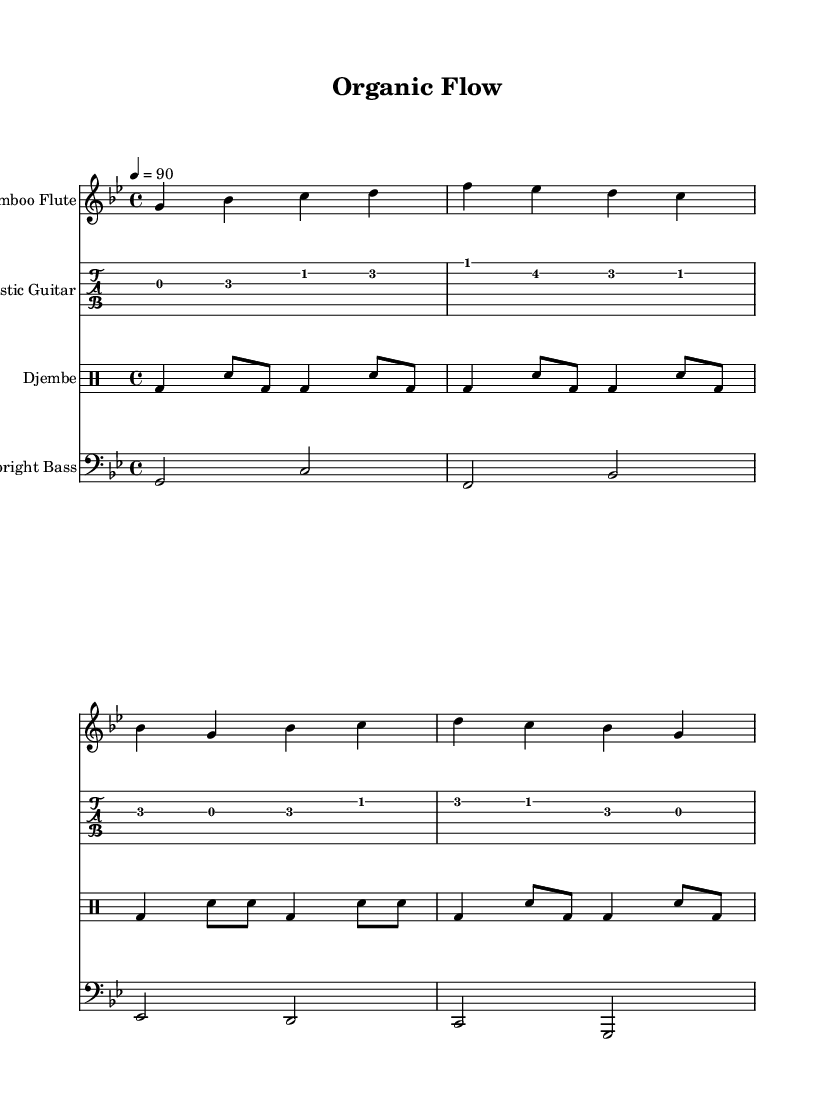What is the key signature of this music? The key signature is G minor, which has two flats (B flat and E flat).
Answer: G minor What is the time signature of the piece? The time signature is indicated prominently at the beginning and is 4/4, which means there are four beats in a measure.
Answer: 4/4 What is the tempo marking of the music? The tempo marking shows that the piece is to be played at 90 beats per minute, indicated using the quarter note symbol for tempo.
Answer: 90 How many instruments are featured in this piece? The score shows four distinct parts for different instruments: Bamboo Flute, Acoustic Guitar, Djembe, and Upright Bass, thus revealing the number of instruments.
Answer: Four Which instrument plays the melodic line? The Bamboo Flute is typically responsible for the melodic line in this composition and is written in the treble staff at the top of the score, showcasing its melody.
Answer: Bamboo Flute What percussion instrument is used in this arrangement? The Djembe is clearly indicated in the score as the percussion instrument that helps establish the rhythmic foundation.
Answer: Djembe What is the rhythmic structure represented in the djembe part? The rhythmic structure involves a pattern of bass and snare strokes within the 4/4 time, represented visually through quarter and eighth notes, which are essential for Hip Hop's rhythmic feel.
Answer: Alternating bass and snare patterns 